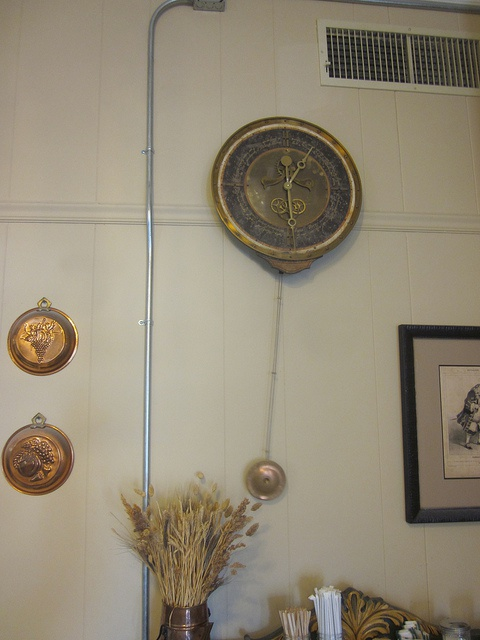Describe the objects in this image and their specific colors. I can see clock in gray and black tones and vase in gray, black, and maroon tones in this image. 